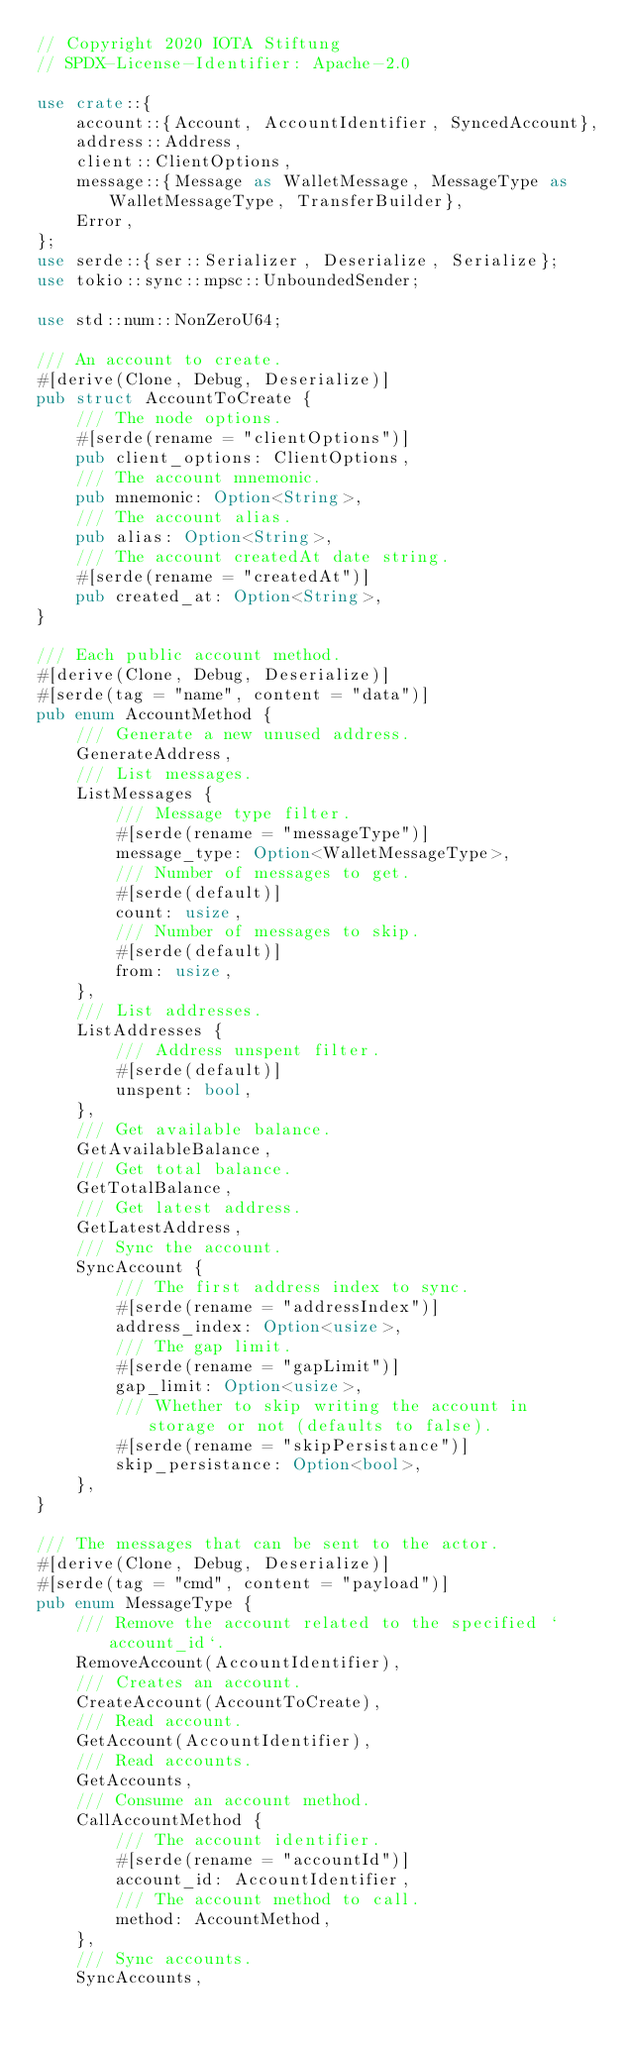Convert code to text. <code><loc_0><loc_0><loc_500><loc_500><_Rust_>// Copyright 2020 IOTA Stiftung
// SPDX-License-Identifier: Apache-2.0

use crate::{
    account::{Account, AccountIdentifier, SyncedAccount},
    address::Address,
    client::ClientOptions,
    message::{Message as WalletMessage, MessageType as WalletMessageType, TransferBuilder},
    Error,
};
use serde::{ser::Serializer, Deserialize, Serialize};
use tokio::sync::mpsc::UnboundedSender;

use std::num::NonZeroU64;

/// An account to create.
#[derive(Clone, Debug, Deserialize)]
pub struct AccountToCreate {
    /// The node options.
    #[serde(rename = "clientOptions")]
    pub client_options: ClientOptions,
    /// The account mnemonic.
    pub mnemonic: Option<String>,
    /// The account alias.
    pub alias: Option<String>,
    /// The account createdAt date string.
    #[serde(rename = "createdAt")]
    pub created_at: Option<String>,
}

/// Each public account method.
#[derive(Clone, Debug, Deserialize)]
#[serde(tag = "name", content = "data")]
pub enum AccountMethod {
    /// Generate a new unused address.
    GenerateAddress,
    /// List messages.
    ListMessages {
        /// Message type filter.
        #[serde(rename = "messageType")]
        message_type: Option<WalletMessageType>,
        /// Number of messages to get.
        #[serde(default)]
        count: usize,
        /// Number of messages to skip.
        #[serde(default)]
        from: usize,
    },
    /// List addresses.
    ListAddresses {
        /// Address unspent filter.
        #[serde(default)]
        unspent: bool,
    },
    /// Get available balance.
    GetAvailableBalance,
    /// Get total balance.
    GetTotalBalance,
    /// Get latest address.
    GetLatestAddress,
    /// Sync the account.
    SyncAccount {
        /// The first address index to sync.
        #[serde(rename = "addressIndex")]
        address_index: Option<usize>,
        /// The gap limit.
        #[serde(rename = "gapLimit")]
        gap_limit: Option<usize>,
        /// Whether to skip writing the account in storage or not (defaults to false).
        #[serde(rename = "skipPersistance")]
        skip_persistance: Option<bool>,
    },
}

/// The messages that can be sent to the actor.
#[derive(Clone, Debug, Deserialize)]
#[serde(tag = "cmd", content = "payload")]
pub enum MessageType {
    /// Remove the account related to the specified `account_id`.
    RemoveAccount(AccountIdentifier),
    /// Creates an account.
    CreateAccount(AccountToCreate),
    /// Read account.
    GetAccount(AccountIdentifier),
    /// Read accounts.
    GetAccounts,
    /// Consume an account method.
    CallAccountMethod {
        /// The account identifier.
        #[serde(rename = "accountId")]
        account_id: AccountIdentifier,
        /// The account method to call.
        method: AccountMethod,
    },
    /// Sync accounts.
    SyncAccounts,</code> 